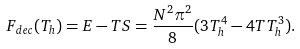Convert formula to latex. <formula><loc_0><loc_0><loc_500><loc_500>F _ { d e c } ( T _ { h } ) = E - T S = \frac { N ^ { 2 } \pi ^ { 2 } } { 8 } ( 3 T _ { h } ^ { 4 } - 4 T T _ { h } ^ { 3 } ) .</formula> 